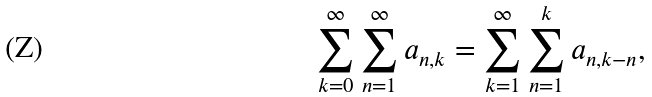<formula> <loc_0><loc_0><loc_500><loc_500>\sum _ { k = 0 } ^ { \infty } \sum _ { n = 1 } ^ { \infty } a _ { n , k } = \sum _ { k = 1 } ^ { \infty } \sum _ { n = 1 } ^ { k } a _ { n , k - n } ,</formula> 